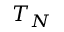Convert formula to latex. <formula><loc_0><loc_0><loc_500><loc_500>T _ { N }</formula> 